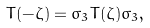<formula> <loc_0><loc_0><loc_500><loc_500>T ( - \zeta ) = \sigma _ { 3 } T ( \zeta ) \sigma _ { 3 } ,</formula> 